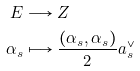Convert formula to latex. <formula><loc_0><loc_0><loc_500><loc_500>E & \longrightarrow Z \\ \alpha _ { s } & \longmapsto \frac { ( \alpha _ { s } , \alpha _ { s } ) } { 2 } a _ { s } ^ { \vee }</formula> 